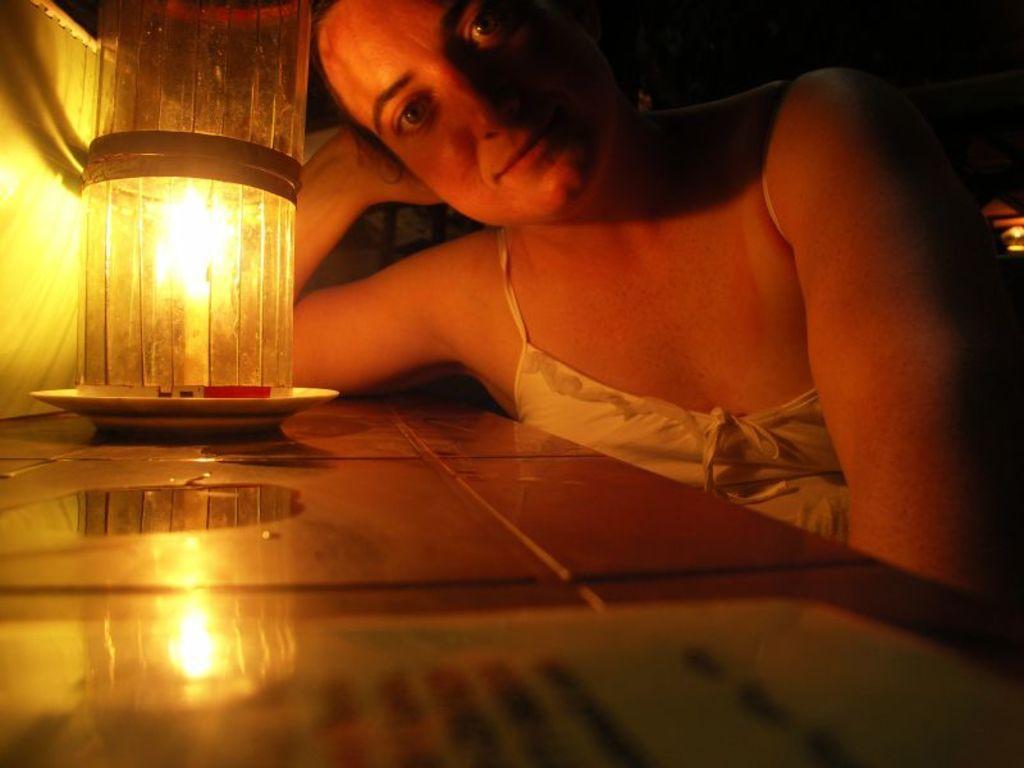Please provide a concise description of this image. In this image I can see a person and the person is wearing white color dress. In front I can see a candle in the plate and the plate is on the table. 